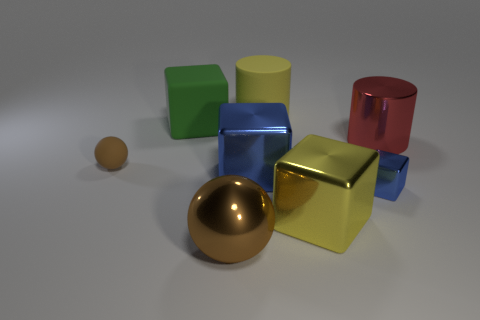Add 2 big blue metallic objects. How many objects exist? 10 Subtract all red cylinders. How many cylinders are left? 1 Subtract all small shiny blocks. How many blocks are left? 3 Subtract 3 blocks. How many blocks are left? 1 Subtract all yellow blocks. Subtract all red balls. How many blocks are left? 3 Subtract all cyan blocks. How many green balls are left? 0 Subtract all big yellow shiny cylinders. Subtract all brown matte things. How many objects are left? 7 Add 6 small brown balls. How many small brown balls are left? 7 Add 3 yellow cubes. How many yellow cubes exist? 4 Subtract 0 cyan cylinders. How many objects are left? 8 